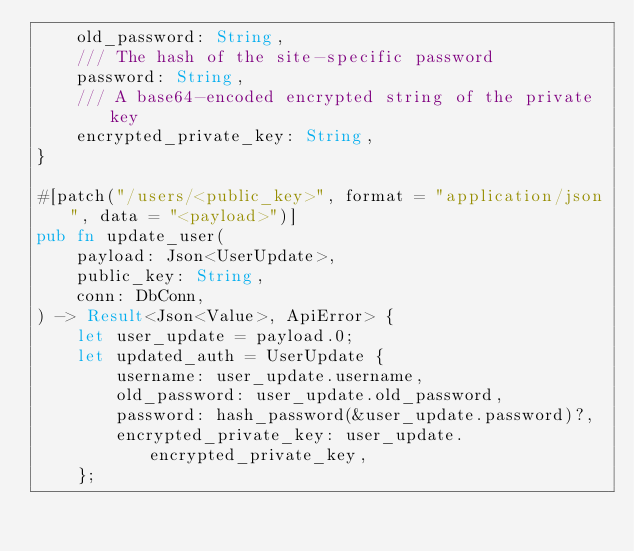<code> <loc_0><loc_0><loc_500><loc_500><_Rust_>    old_password: String,
    /// The hash of the site-specific password
    password: String,
    /// A base64-encoded encrypted string of the private key
    encrypted_private_key: String,
}

#[patch("/users/<public_key>", format = "application/json", data = "<payload>")]
pub fn update_user(
    payload: Json<UserUpdate>,
    public_key: String,
    conn: DbConn,
) -> Result<Json<Value>, ApiError> {
    let user_update = payload.0;
    let updated_auth = UserUpdate {
        username: user_update.username,
        old_password: user_update.old_password,
        password: hash_password(&user_update.password)?,
        encrypted_private_key: user_update.encrypted_private_key,
    };
</code> 